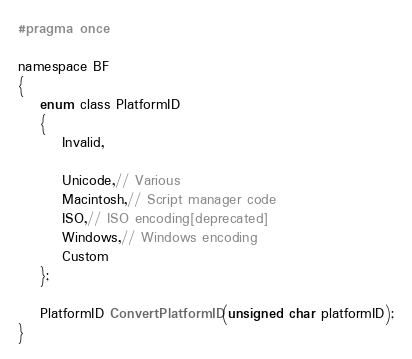<code> <loc_0><loc_0><loc_500><loc_500><_C_>#pragma once

namespace BF
{
	enum class PlatformID
	{
		Invalid,

		Unicode,// Various
		Macintosh,// Script manager code
		ISO,// ISO encoding[deprecated]
		Windows,// Windows encoding
		Custom
	};

	PlatformID ConvertPlatformID(unsigned char platformID);
}
</code> 